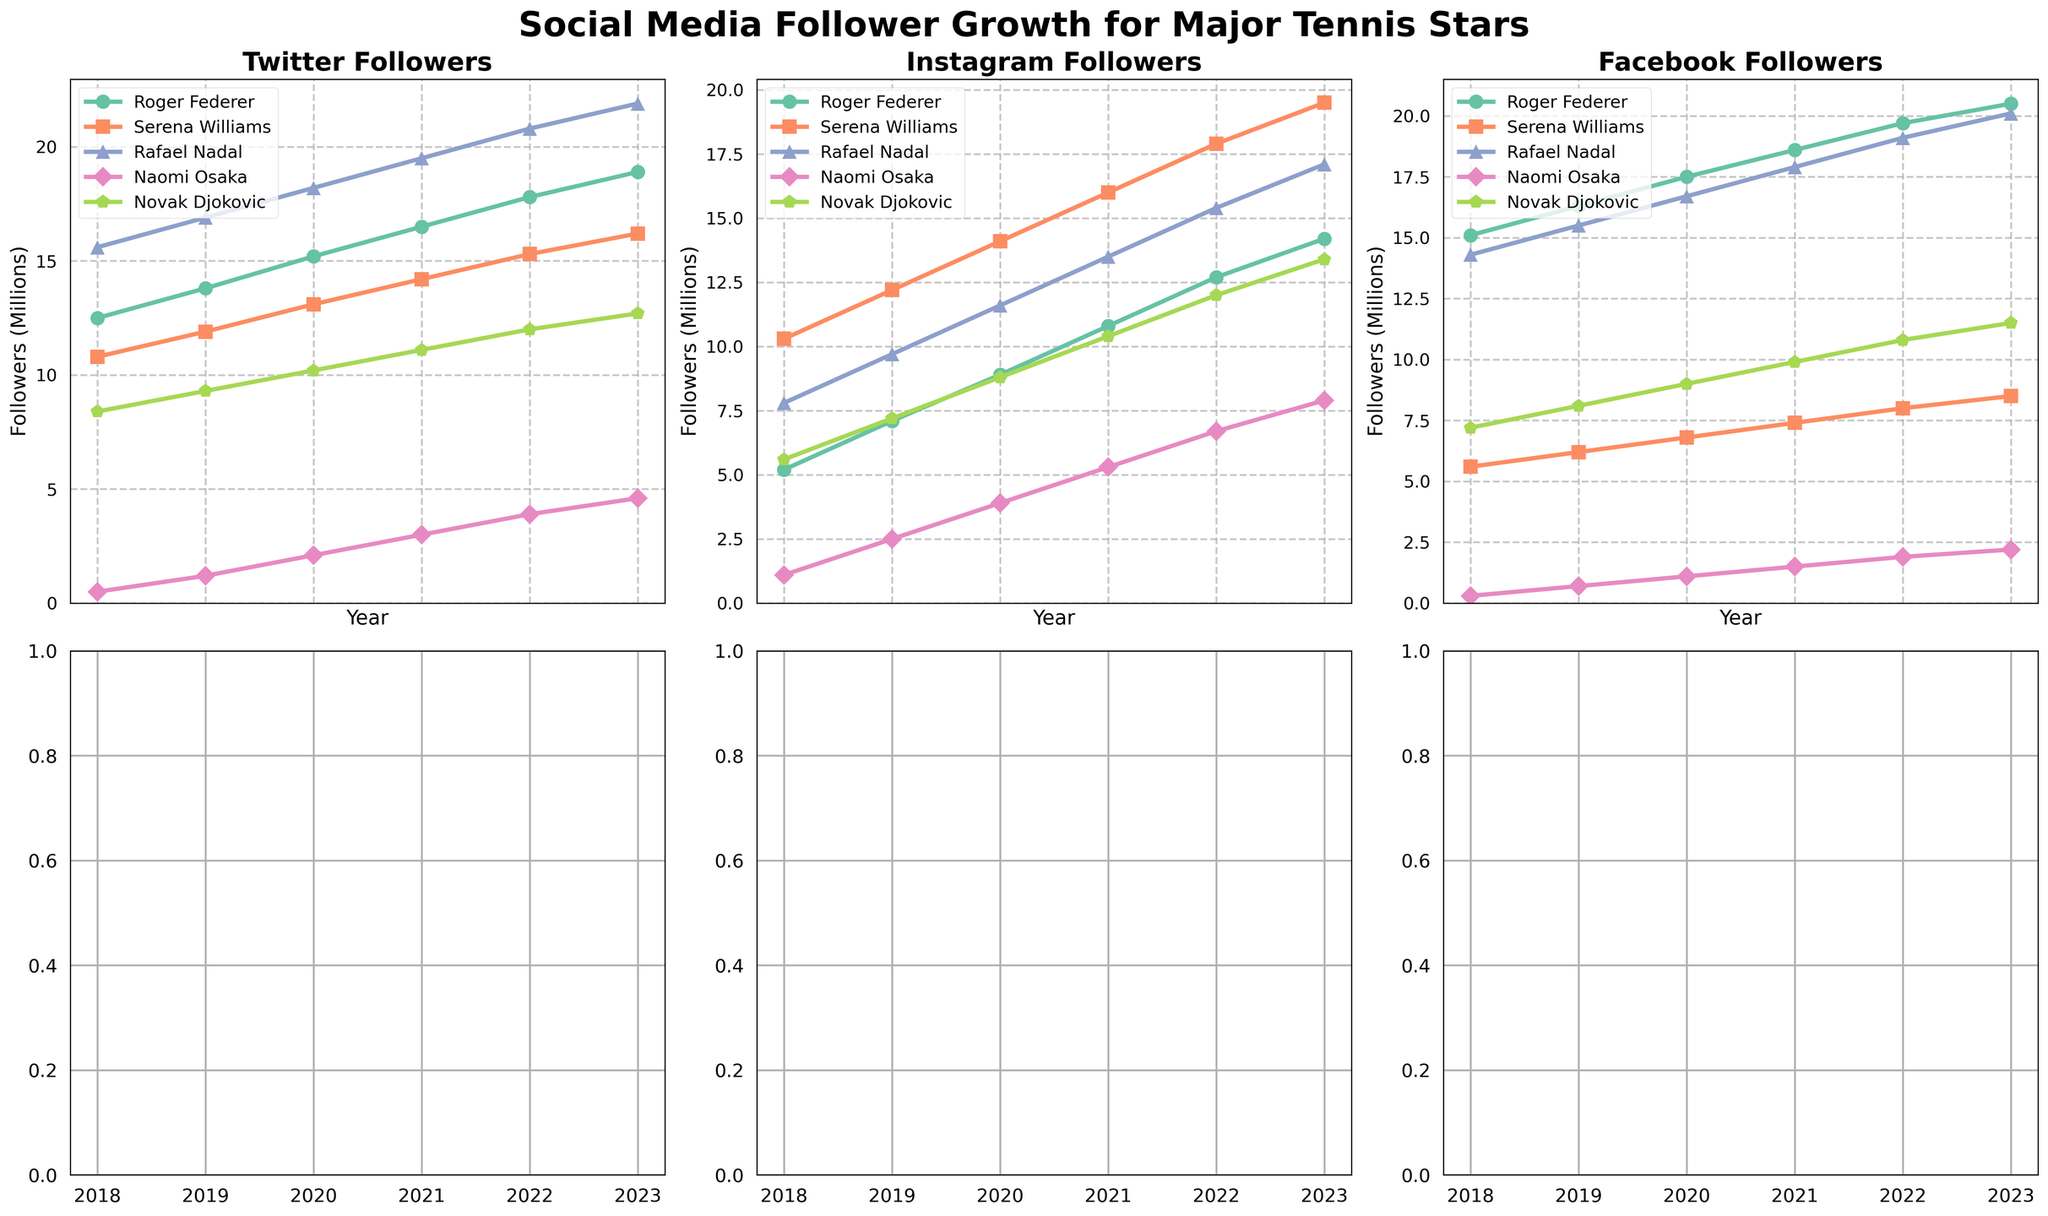Which player had the highest overall Instagram followers in 2023? Look at the Instagram subplot for all players' lines in 2023. Serena Williams' line is the highest.
Answer: Serena Williams How did Naomi Osaka's Twitter followers grow from 2018 to 2023? Examine Naomi Osaka's line in the Twitter subplot. Her followers increased steadily from 0.5 million in 2018 to 4.6 million in 2023.
Answer: Steadily increased from 0.5 million to 4.6 million Which player had the smallest change in Facebook followers from 2018 to 2023? Look at all players' lines in the Facebook subplot between 2018 and 2023. Serena Williams had the smallest change, from 5.6 million to 8.5 million (a change of 2.9 million).
Answer: Serena Williams Who had more Twitter followers in 2020, Roger Federer or Rafael Nadal? Compare Roger Federer's and Rafael Nadal's lines in the Twitter subplot for the year 2020. Rafael Nadal had 18.2 million while Roger Federer had 15.2 million.
Answer: Rafael Nadal Which platform did Novak Djokovic have the most followers on in 2023? Examine the subplots for Novak Djokovic's highest 2023 datapoints. Twitter: 12.7 million, Instagram: 13.4 million, Facebook: 11.5 million. Instagram is the highest.
Answer: Instagram What is the average yearly growth in Instagram followers for Serena Williams from 2018 to 2023? Calculate the difference in followers between 2023 and 2018 (19.5 - 10.3 = 9.2 million). Divide by the number of years (2023 - 2018 = 5 years). 9.2 / 5 = 1.84 million per year.
Answer: 1.84 million per year Which player had the second highest Twitter followers in 2021? Look at the Twitter subplot for the year 2021. Roger Federer had the highest, then Rafael Nadal with 19.5 million.
Answer: Rafael Nadal How much more Instagram followers did Roger Federer have in 2023 compared to 2018? Subtract Roger Federer's Instagram followers in 2018 from those in 2023. 14.2 million - 5.2 million = 9 million.
Answer: 9 million Which player saw a greater increase in Facebook followers from 2018 to 2023, Rafael Nadal or Novak Djokovic? Compare the increases: Rafael Nadal from 2018 to 2023 (20.1 - 14.3 = 5.8 million), Novak Djokovic from 2018 to 2023 (11.5 - 7.2 = 4.3 million). Rafael Nadal had a greater increase.
Answer: Rafael Nadal 